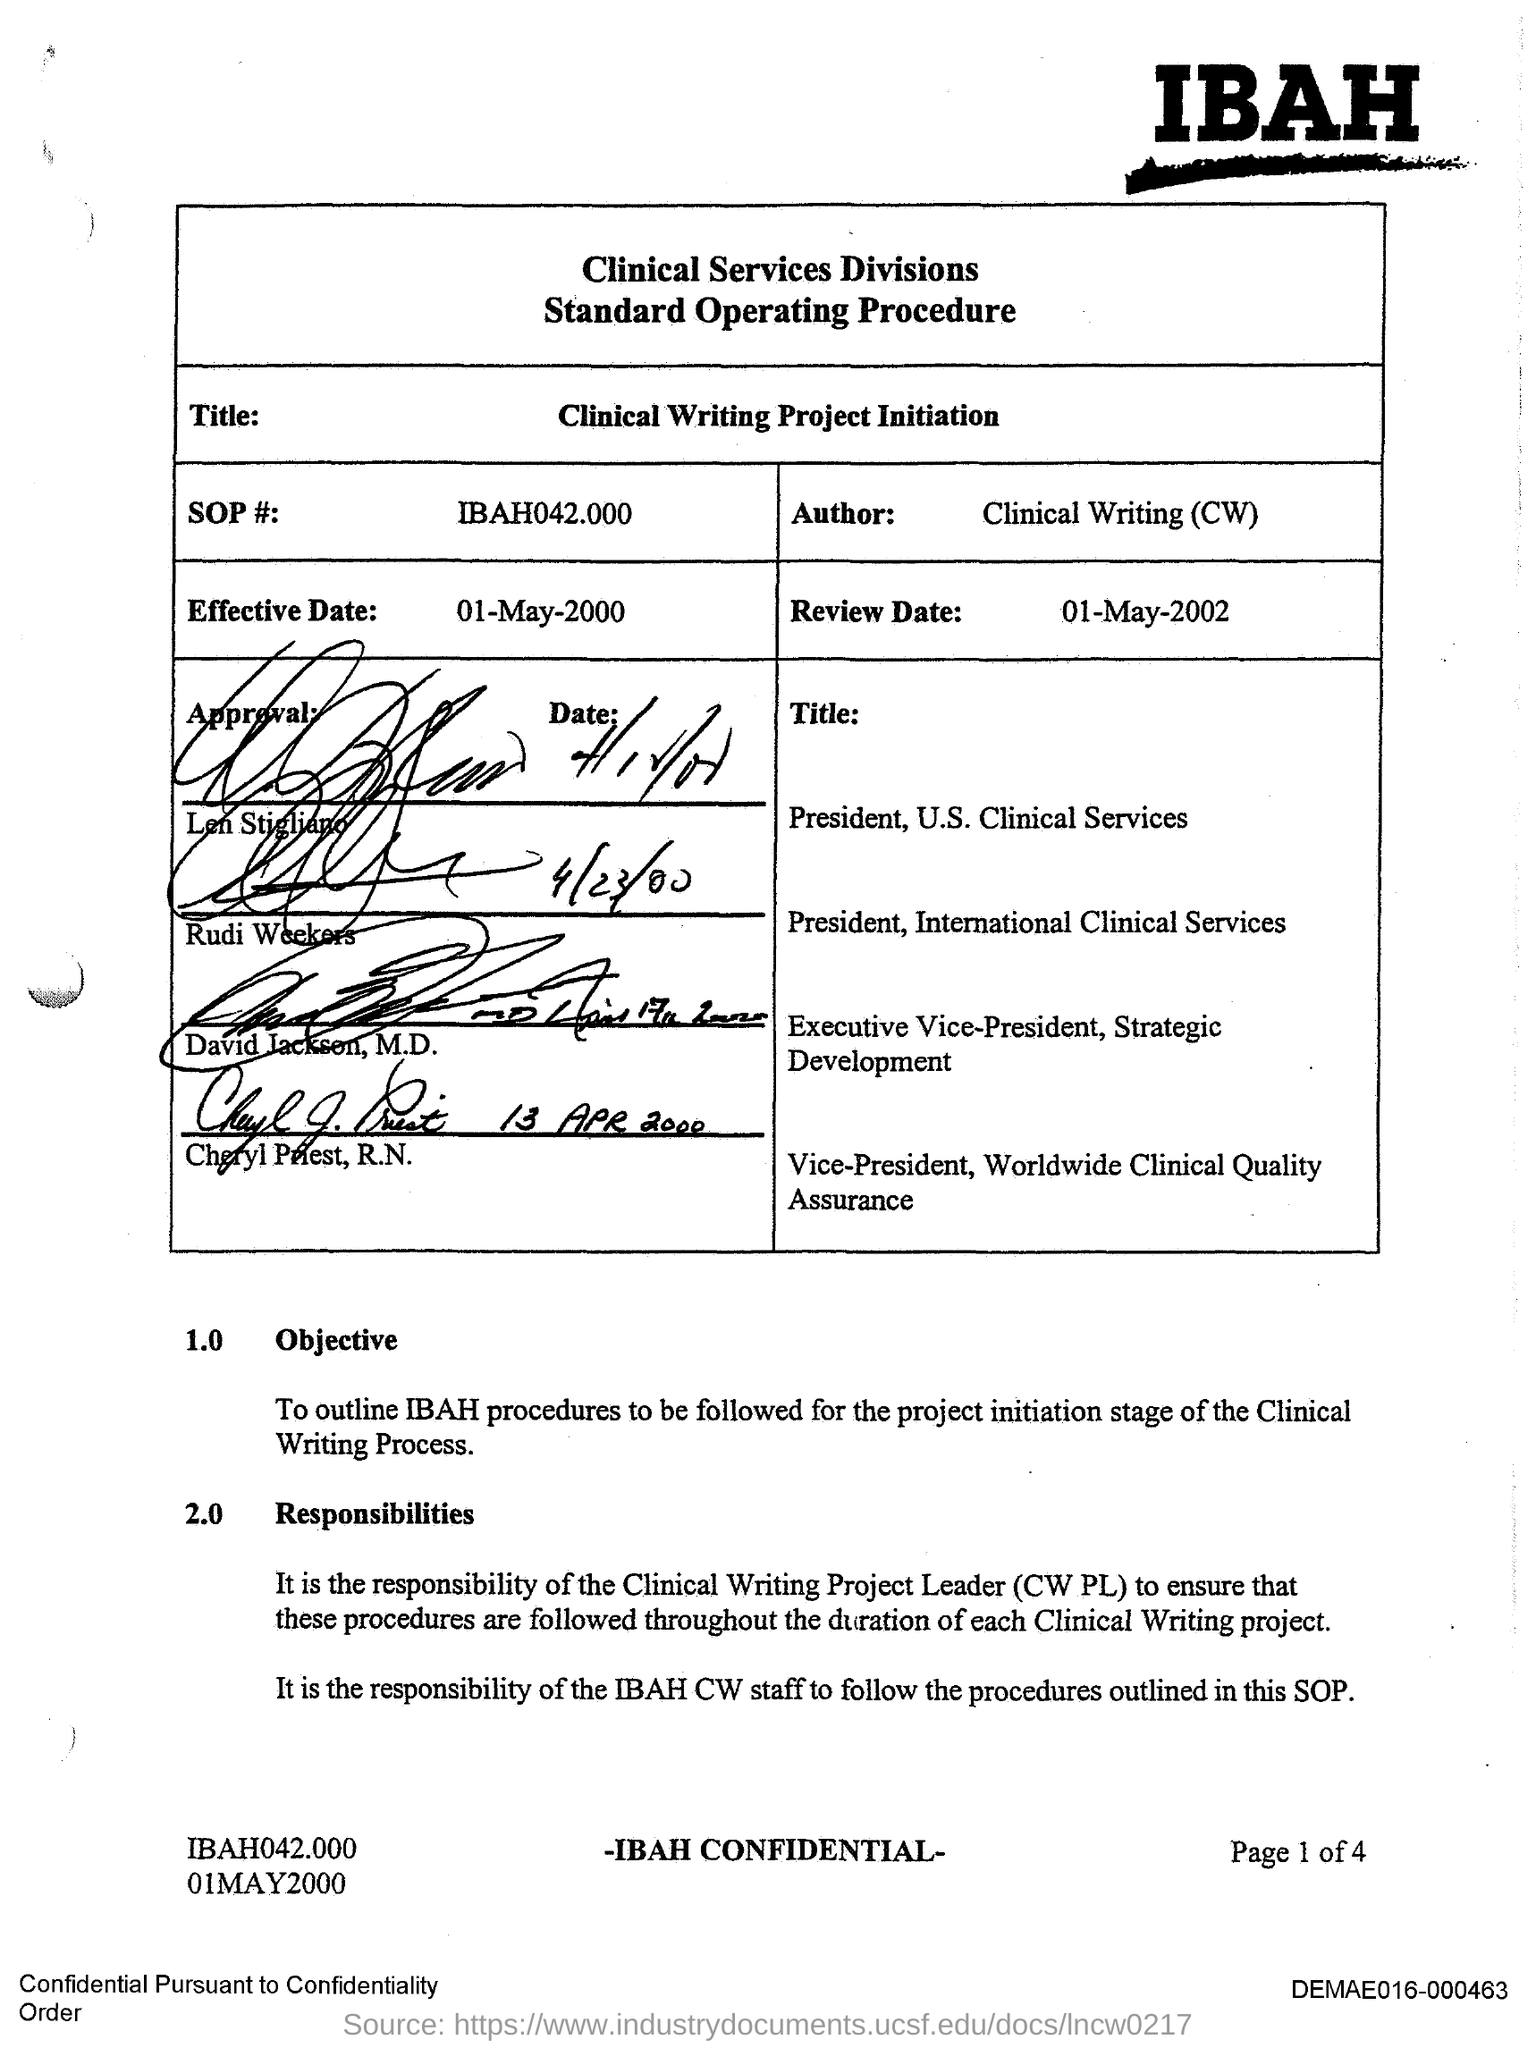Who is the Author?
Offer a terse response. Clinical Writing(CW). 